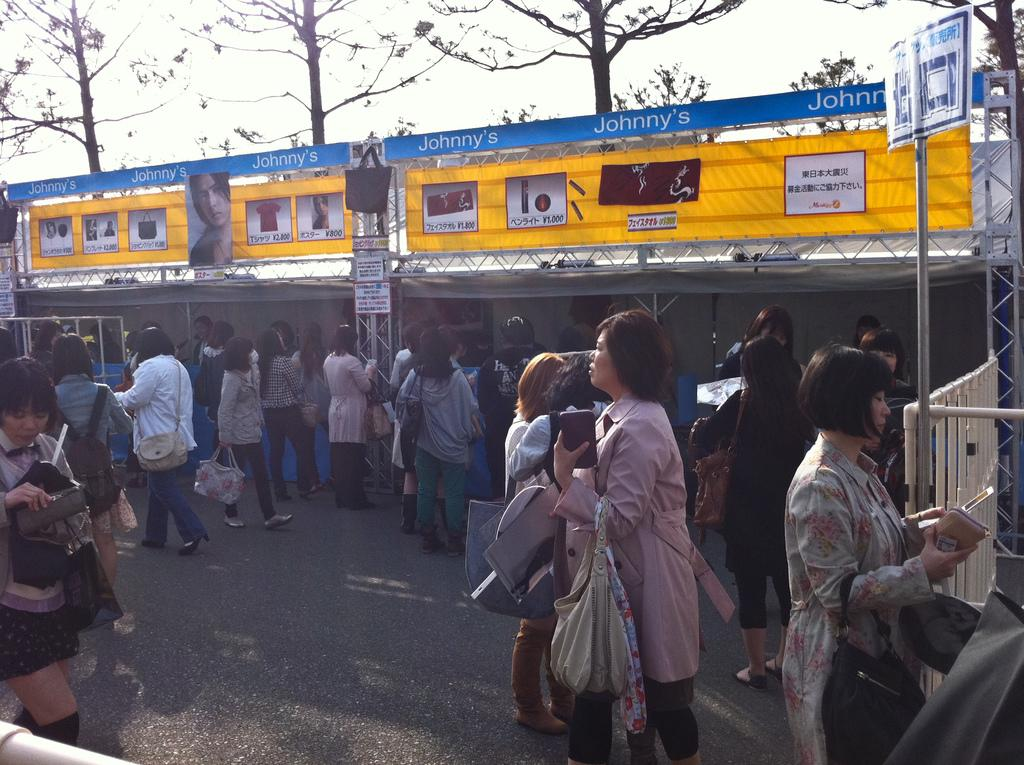What are the people in the image doing? The people in the image are walking on the road. What can be seen in the background of the image? There are trees and poles in the background of the image. What type of underwear is the cat wearing in the image? There is no cat present in the image, and therefore no underwear can be observed. 